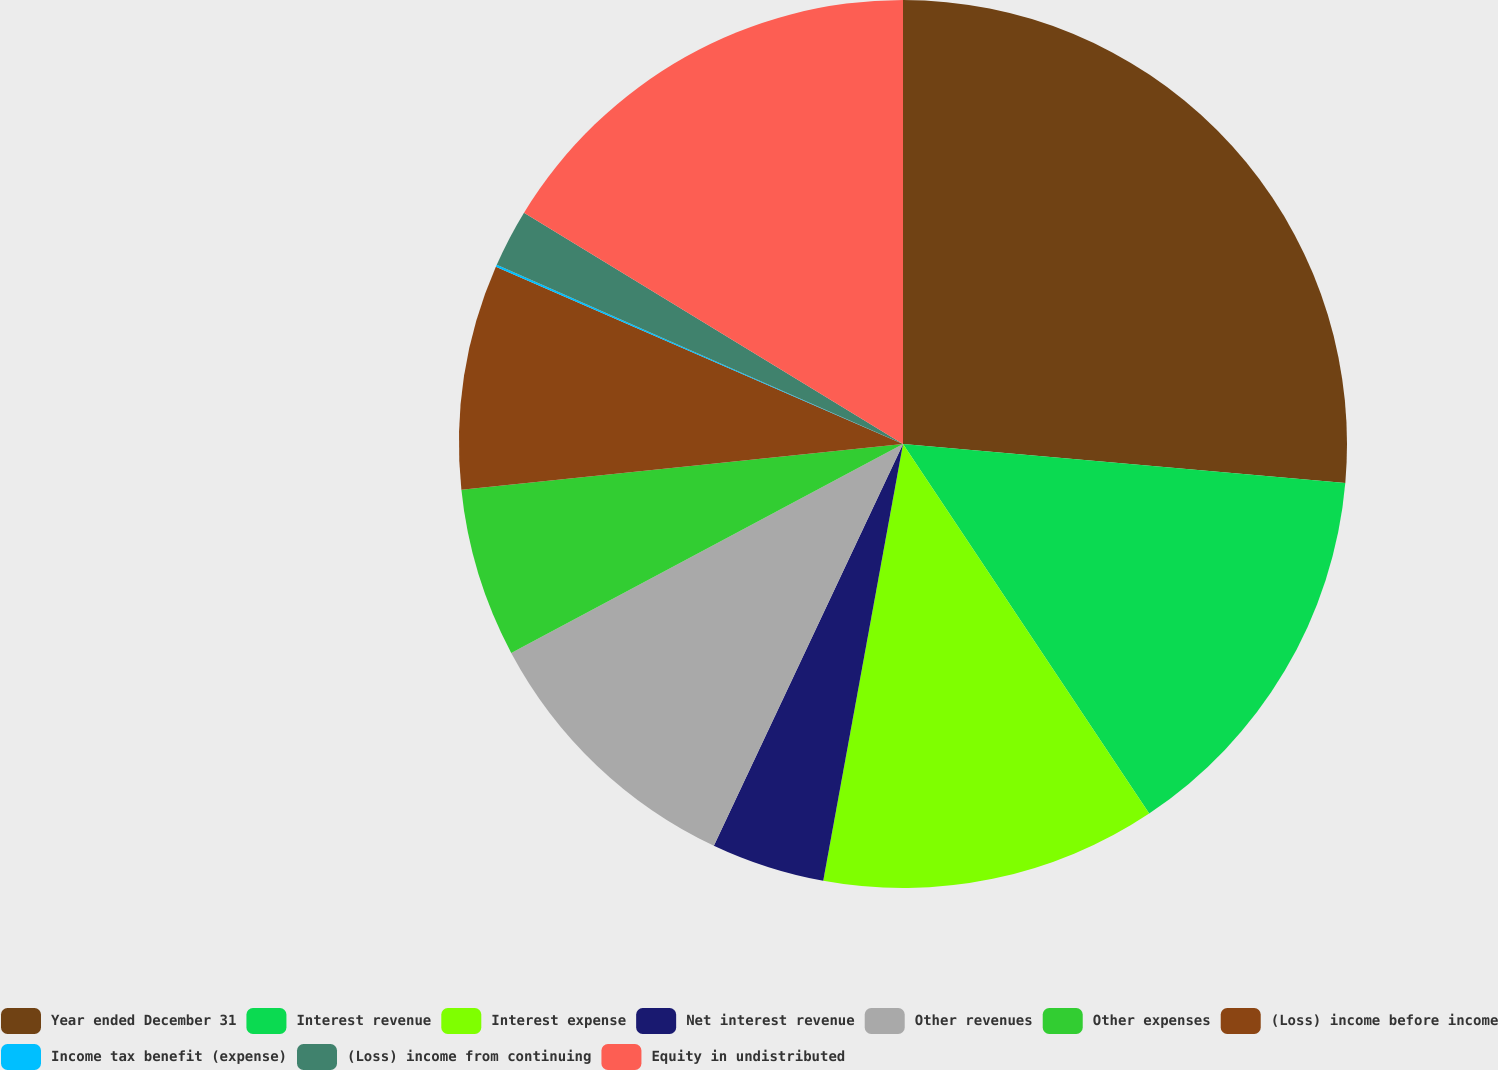<chart> <loc_0><loc_0><loc_500><loc_500><pie_chart><fcel>Year ended December 31<fcel>Interest revenue<fcel>Interest expense<fcel>Net interest revenue<fcel>Other revenues<fcel>Other expenses<fcel>(Loss) income before income<fcel>Income tax benefit (expense)<fcel>(Loss) income from continuing<fcel>Equity in undistributed<nl><fcel>26.4%<fcel>14.25%<fcel>12.23%<fcel>4.13%<fcel>10.2%<fcel>6.15%<fcel>8.18%<fcel>0.08%<fcel>2.11%<fcel>16.28%<nl></chart> 